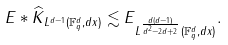<formula> <loc_0><loc_0><loc_500><loc_500>\| E \ast \widehat { K } \| _ { L ^ { d - 1 } ( { \mathbb { F } _ { q } ^ { d } } , d x ) } \lesssim \| E \| _ { L ^ { \frac { d ( d - 1 ) } { d ^ { 2 } - 2 d + 2 } } ( { \mathbb { F } _ { q } ^ { d } } , d x ) } .</formula> 